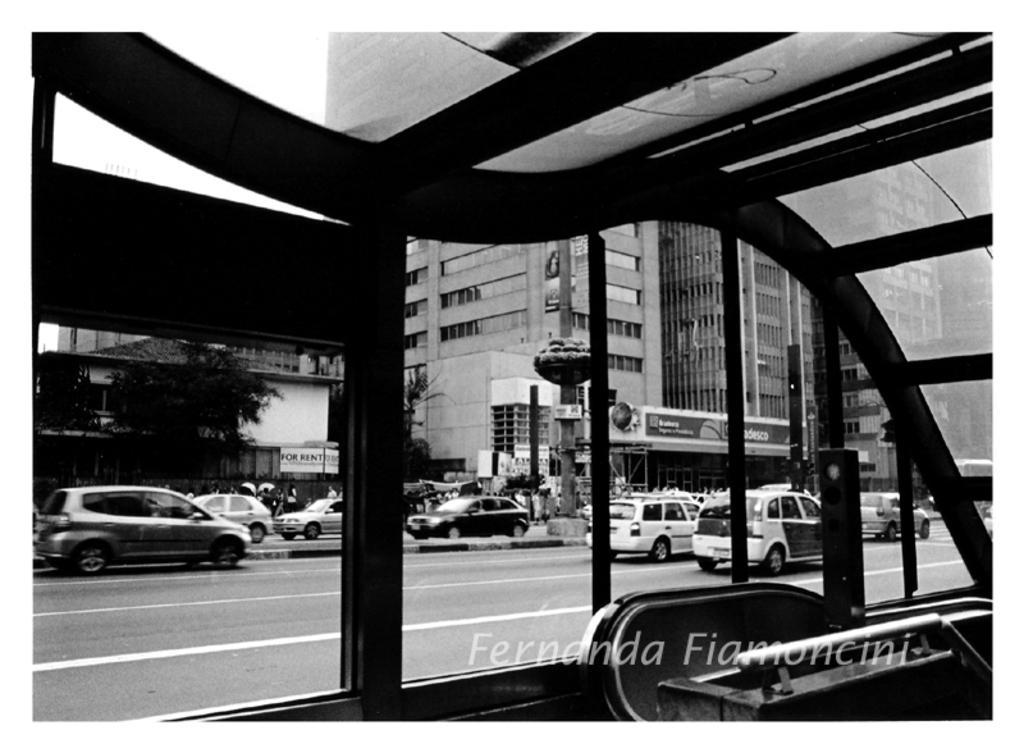In one or two sentences, can you explain what this image depicts? On the bottom right, there is a watermark. At the bottom of this image, we can see there are glass windows. Through these glass windows, we can see there are vehicles on the road. In the background, there are trees, poles and there is the sky. 